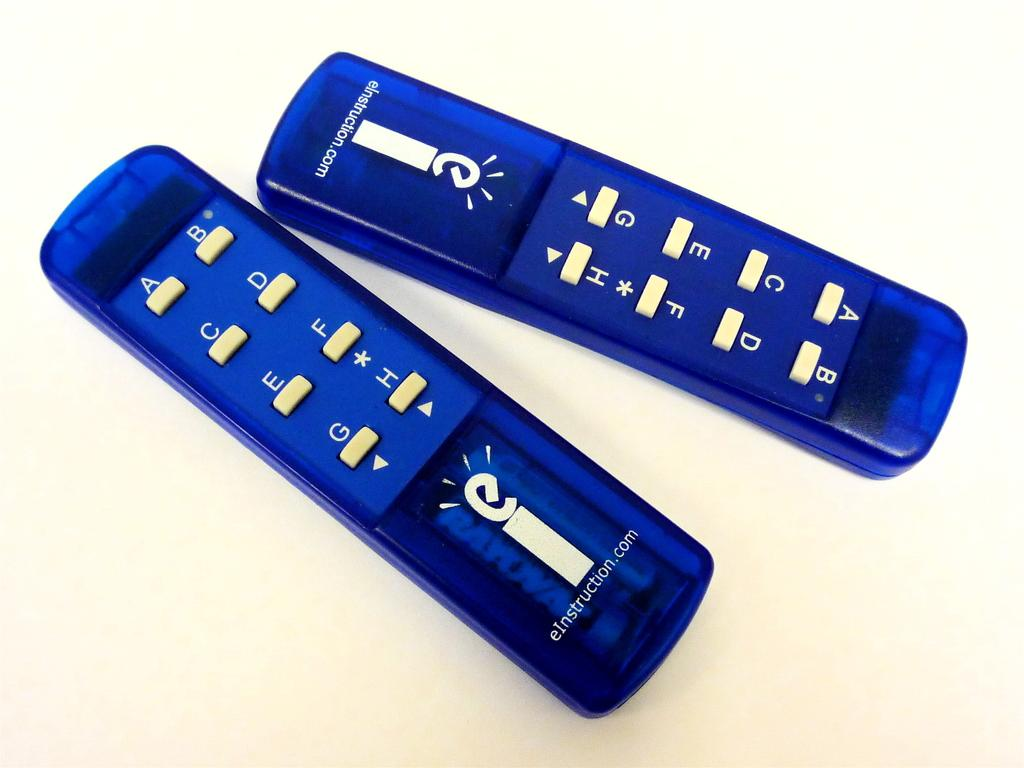<image>
Offer a succinct explanation of the picture presented. Remote control for eInstruction next to another one. 